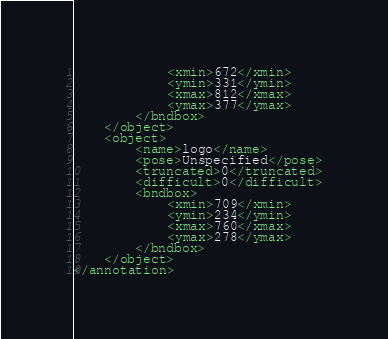<code> <loc_0><loc_0><loc_500><loc_500><_XML_>			<xmin>672</xmin>
			<ymin>331</ymin>
			<xmax>812</xmax>
			<ymax>377</ymax>
		</bndbox>
	</object>
	<object>
		<name>logo</name>
		<pose>Unspecified</pose>
		<truncated>0</truncated>
		<difficult>0</difficult>
		<bndbox>
			<xmin>709</xmin>
			<ymin>234</ymin>
			<xmax>760</xmax>
			<ymax>278</ymax>
		</bndbox>
	</object>
</annotation>
</code> 